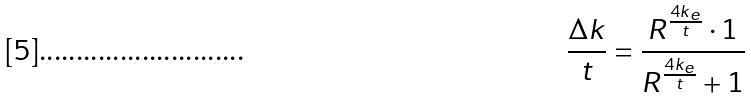Convert formula to latex. <formula><loc_0><loc_0><loc_500><loc_500>\frac { \Delta k } { t } = \frac { R ^ { \frac { 4 k _ { e } } { t } } \cdot 1 } { R ^ { \frac { 4 k _ { e } } { t } } + 1 }</formula> 